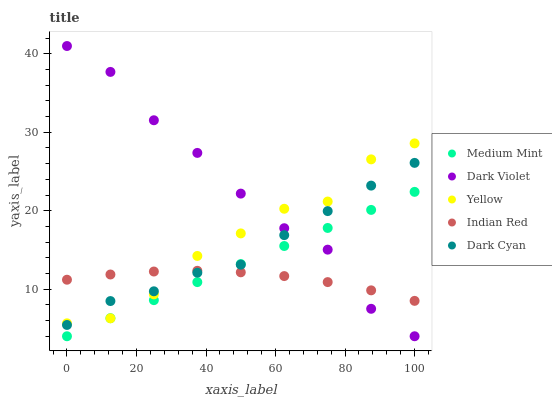Does Indian Red have the minimum area under the curve?
Answer yes or no. Yes. Does Dark Violet have the maximum area under the curve?
Answer yes or no. Yes. Does Dark Cyan have the minimum area under the curve?
Answer yes or no. No. Does Dark Cyan have the maximum area under the curve?
Answer yes or no. No. Is Medium Mint the smoothest?
Answer yes or no. Yes. Is Dark Violet the roughest?
Answer yes or no. Yes. Is Dark Cyan the smoothest?
Answer yes or no. No. Is Dark Cyan the roughest?
Answer yes or no. No. Does Medium Mint have the lowest value?
Answer yes or no. Yes. Does Dark Cyan have the lowest value?
Answer yes or no. No. Does Dark Violet have the highest value?
Answer yes or no. Yes. Does Dark Cyan have the highest value?
Answer yes or no. No. Does Indian Red intersect Yellow?
Answer yes or no. Yes. Is Indian Red less than Yellow?
Answer yes or no. No. Is Indian Red greater than Yellow?
Answer yes or no. No. 